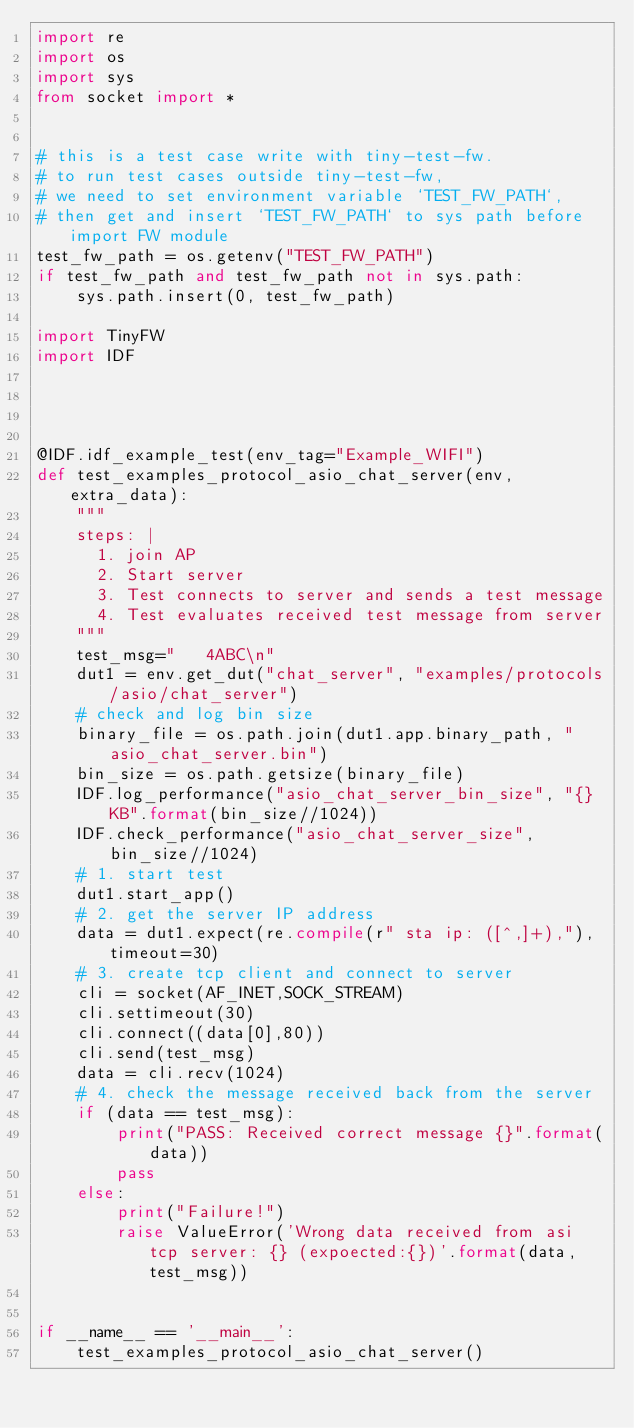Convert code to text. <code><loc_0><loc_0><loc_500><loc_500><_Python_>import re
import os
import sys
from socket import *


# this is a test case write with tiny-test-fw.
# to run test cases outside tiny-test-fw,
# we need to set environment variable `TEST_FW_PATH`,
# then get and insert `TEST_FW_PATH` to sys path before import FW module
test_fw_path = os.getenv("TEST_FW_PATH")
if test_fw_path and test_fw_path not in sys.path:
    sys.path.insert(0, test_fw_path)

import TinyFW
import IDF




@IDF.idf_example_test(env_tag="Example_WIFI")
def test_examples_protocol_asio_chat_server(env, extra_data):
    """
    steps: |
      1. join AP
      2. Start server
      3. Test connects to server and sends a test message
      4. Test evaluates received test message from server
    """
    test_msg="   4ABC\n"
    dut1 = env.get_dut("chat_server", "examples/protocols/asio/chat_server")
    # check and log bin size
    binary_file = os.path.join(dut1.app.binary_path, "asio_chat_server.bin")
    bin_size = os.path.getsize(binary_file)
    IDF.log_performance("asio_chat_server_bin_size", "{}KB".format(bin_size//1024))
    IDF.check_performance("asio_chat_server_size", bin_size//1024)
    # 1. start test
    dut1.start_app()
    # 2. get the server IP address
    data = dut1.expect(re.compile(r" sta ip: ([^,]+),"), timeout=30)
    # 3. create tcp client and connect to server
    cli = socket(AF_INET,SOCK_STREAM)
    cli.settimeout(30)
    cli.connect((data[0],80))
    cli.send(test_msg)
    data = cli.recv(1024)
    # 4. check the message received back from the server
    if (data == test_msg):
        print("PASS: Received correct message {}".format(data))
        pass
    else:
        print("Failure!")
        raise ValueError('Wrong data received from asi tcp server: {} (expoected:{})'.format(data, test_msg))


if __name__ == '__main__':
    test_examples_protocol_asio_chat_server()
</code> 